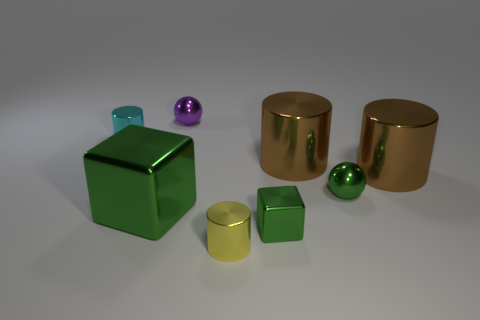What number of other things are the same shape as the tiny purple shiny thing?
Provide a succinct answer. 1. The metal block that is the same size as the cyan shiny cylinder is what color?
Your response must be concise. Green. Are there an equal number of metal objects that are left of the big green metallic cube and purple balls?
Offer a terse response. Yes. There is a shiny object that is to the left of the small yellow object and in front of the cyan object; what is its shape?
Keep it short and to the point. Cube. Do the cyan object and the green ball have the same size?
Offer a terse response. Yes. Are there any small green objects made of the same material as the yellow cylinder?
Ensure brevity in your answer.  Yes. The ball that is the same color as the large metal cube is what size?
Your answer should be compact. Small. How many things are left of the large green cube and on the right side of the green ball?
Offer a very short reply. 0. What is the material of the thing to the left of the big metallic cube?
Offer a very short reply. Metal. What number of balls have the same color as the small block?
Provide a short and direct response. 1. 